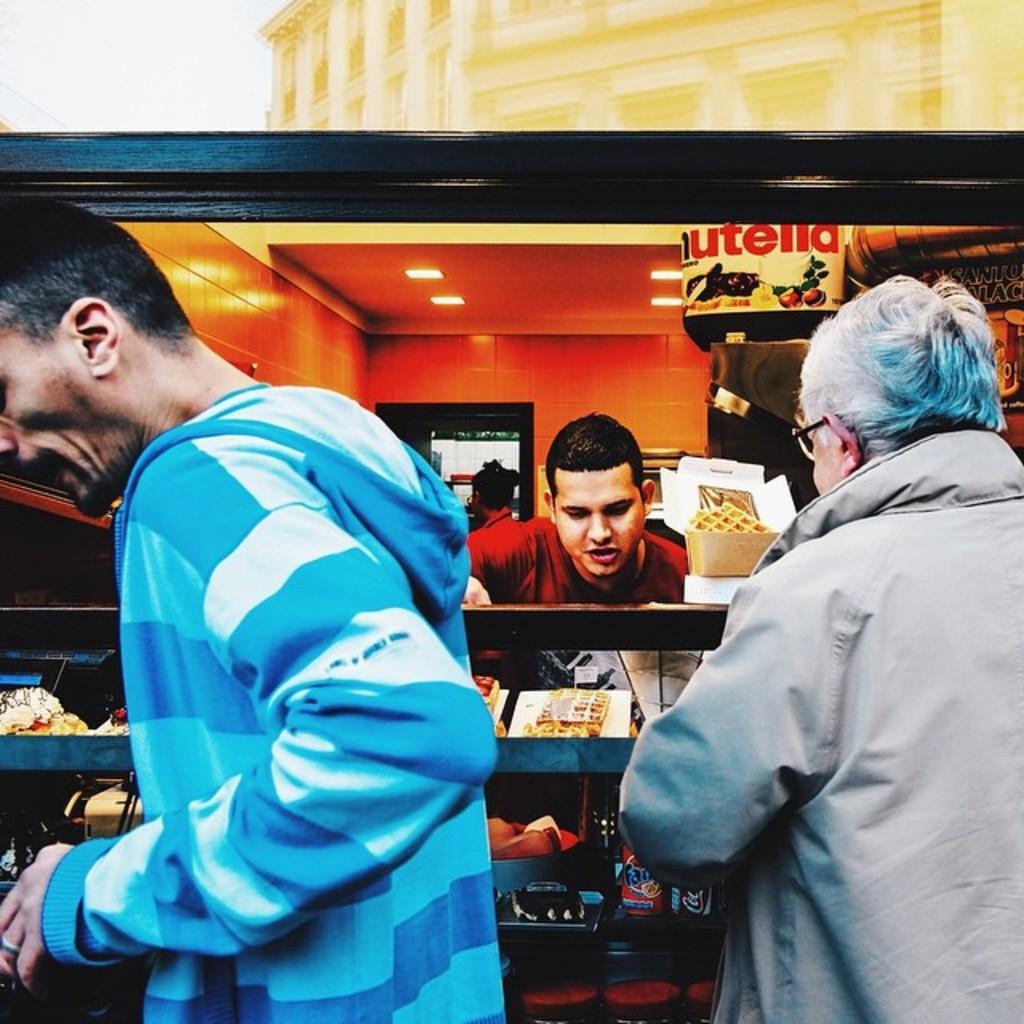Can you describe this image briefly? In the image we can see there are people standing near the food stall and there are food items kept in a glass table. 